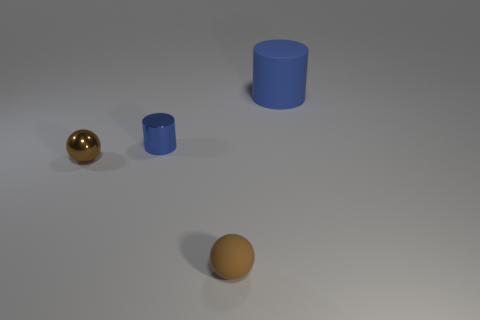What shape is the other shiny thing that is the same size as the brown metallic object?
Provide a short and direct response. Cylinder. Does the small ball behind the small brown matte sphere have the same color as the ball that is right of the small metal cylinder?
Ensure brevity in your answer.  Yes. What number of other objects are there of the same color as the big cylinder?
Keep it short and to the point. 1. Are there any other things that have the same size as the blue matte object?
Offer a very short reply. No. How many other tiny brown metallic objects are the same shape as the brown metal object?
Provide a succinct answer. 0. Are there an equal number of small rubber things behind the brown matte object and brown rubber spheres that are in front of the tiny metallic cylinder?
Ensure brevity in your answer.  No. Is there a tiny ball made of the same material as the big blue thing?
Provide a short and direct response. Yes. Are the tiny blue object and the big cylinder made of the same material?
Offer a terse response. No. What number of green objects are matte objects or tiny metallic cylinders?
Give a very brief answer. 0. Is the number of rubber spheres on the left side of the matte cylinder greater than the number of yellow spheres?
Provide a short and direct response. Yes. 